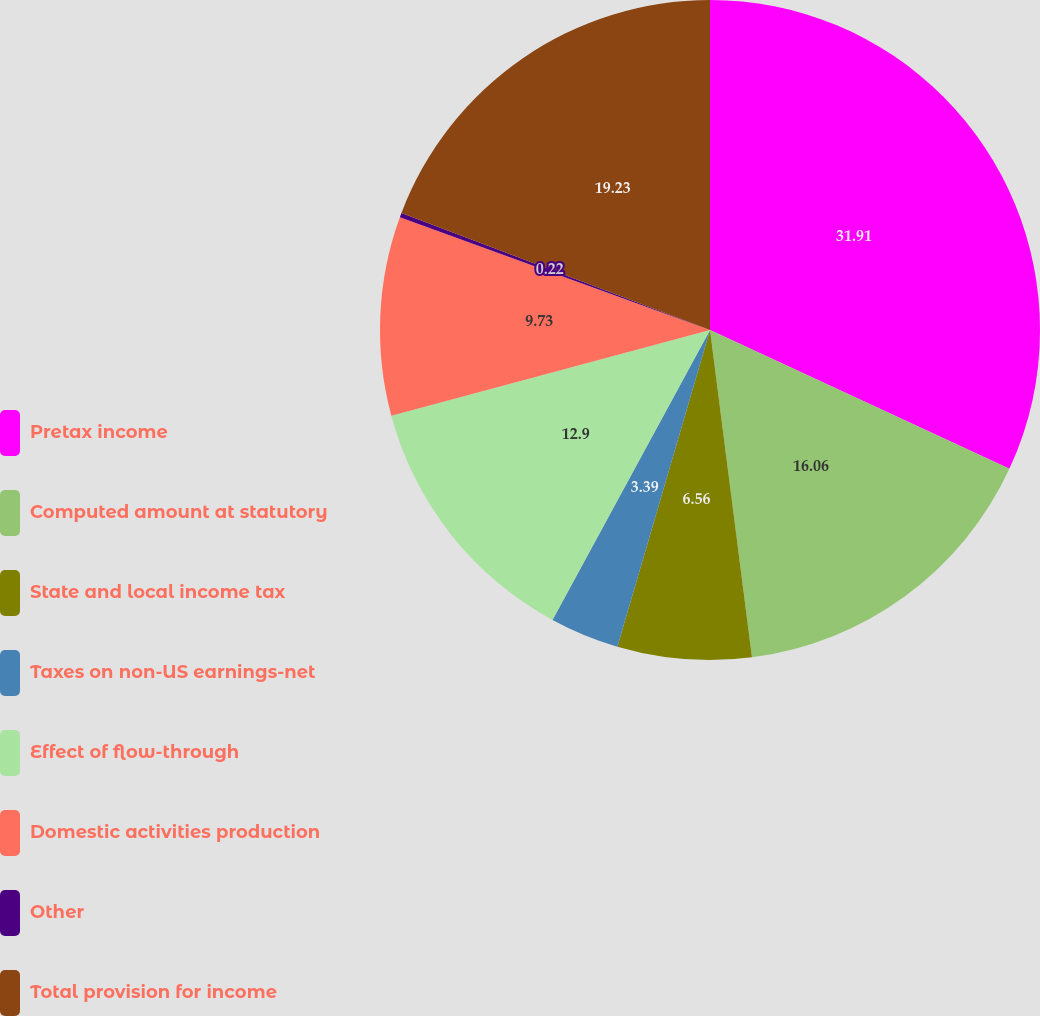Convert chart. <chart><loc_0><loc_0><loc_500><loc_500><pie_chart><fcel>Pretax income<fcel>Computed amount at statutory<fcel>State and local income tax<fcel>Taxes on non-US earnings-net<fcel>Effect of flow-through<fcel>Domestic activities production<fcel>Other<fcel>Total provision for income<nl><fcel>31.91%<fcel>16.06%<fcel>6.56%<fcel>3.39%<fcel>12.9%<fcel>9.73%<fcel>0.22%<fcel>19.23%<nl></chart> 